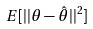Convert formula to latex. <formula><loc_0><loc_0><loc_500><loc_500>E [ | | \theta - \hat { \theta } | | ^ { 2 } ]</formula> 